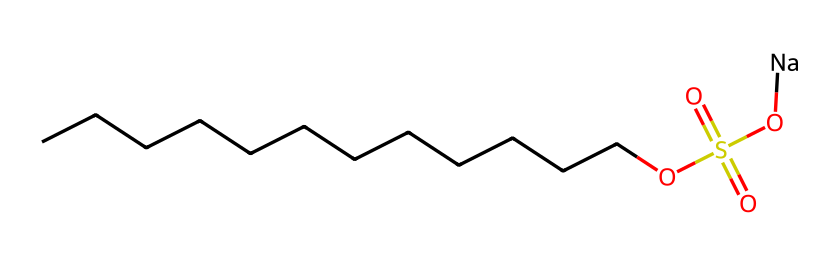What is the total number of carbon atoms in this molecule? The chemical structure shows a long hydrocarbon chain, and by counting the 'C' symbols, there are 12 carbon atoms present in the chain.
Answer: 12 How many oxygen atoms are in sodium lauryl sulfate? Upon examining the structure, there are three 'O' symbols, indicating that there are a total of three oxygen atoms in the molecule.
Answer: 3 What functional groups are present in this compound? By examining the structure, we can identify a sulfonate group (–SO3) and the hydroxyl group (–OH) from the sulfate. Both are indicative of the surfactant properties of this molecule.
Answer: sulfonate, hydroxyl Is sodium lauryl sulfate ionic or covalent? The presence of the sodium ion (Na) and the negatively charged sulfate (–SO4) group indicates that the compound is ionic due to the electrostatic attraction between ions.
Answer: ionic What property of this compound allows it to be a surfactant? The long hydrophobic hydrocarbon tail (from the carbon chain) combined with the hydrophilic sulfate head enables it to reduce surface tension, a key feature of surfactants.
Answer: amphiphilic What is the role of sodium in this chemical? The sodium ion serves to balance the negative charge of the sulfate group, making the compound’s overall charge neutral and increasing its solubility in water, which is essential for its use in shampoos.
Answer: charge balancing, solubility 